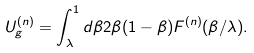<formula> <loc_0><loc_0><loc_500><loc_500>U ^ { ( n ) } _ { g } = \int _ { \lambda } ^ { 1 } d \beta 2 \beta ( 1 - \beta ) F ^ { ( n ) } ( \beta / \lambda ) .</formula> 